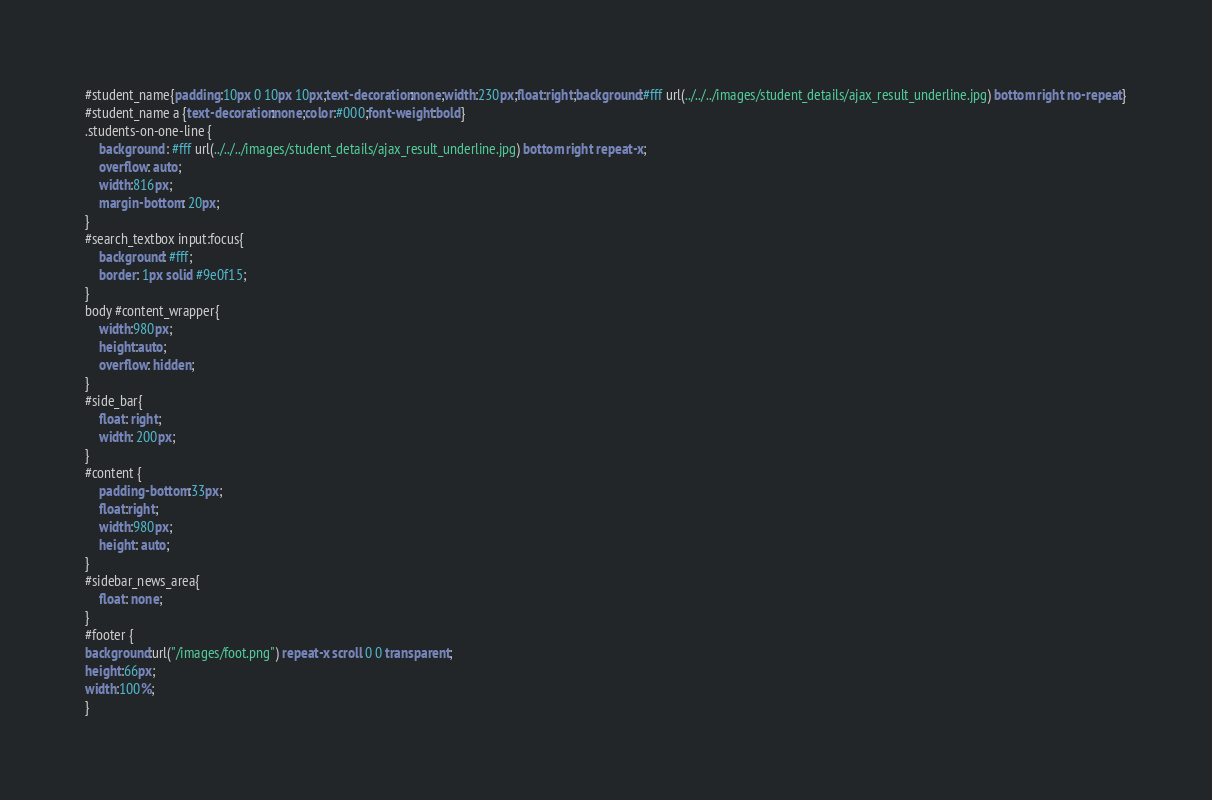Convert code to text. <code><loc_0><loc_0><loc_500><loc_500><_CSS_>#student_name{padding:10px 0 10px 10px;text-decoration:none;width:230px;float:right;background:#fff url(../../../images/student_details/ajax_result_underline.jpg) bottom right no-repeat}
#student_name a {text-decoration:none;color:#000;font-weight:bold}
.students-on-one-line {
    background : #fff url(../../../images/student_details/ajax_result_underline.jpg) bottom right repeat-x;
    overflow: auto;
    width:816px;
    margin-bottom: 20px;
}
#search_textbox input:focus{
    background: #fff;
    border: 1px solid #9e0f15;
}
body #content_wrapper{
    width:980px;
    height:auto;
    overflow: hidden;
}
#side_bar{
    float: right;
    width: 200px;
}
#content {
    padding-bottom:33px;
    float:right;
    width:980px;
    height: auto;
}
#sidebar_news_area{
    float: none;
}
#footer {
background:url("/images/foot.png") repeat-x scroll 0 0 transparent;
height:66px;
width:100%;
}</code> 